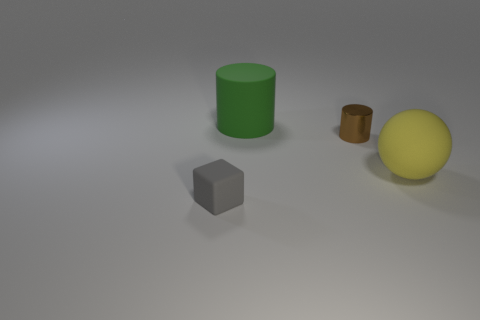Add 1 yellow spheres. How many objects exist? 5 Subtract all balls. How many objects are left? 3 Subtract all yellow rubber balls. Subtract all large spheres. How many objects are left? 2 Add 1 big cylinders. How many big cylinders are left? 2 Add 1 small gray matte blocks. How many small gray matte blocks exist? 2 Subtract 0 brown spheres. How many objects are left? 4 Subtract 2 cylinders. How many cylinders are left? 0 Subtract all gray cylinders. Subtract all brown cubes. How many cylinders are left? 2 Subtract all red blocks. How many brown cylinders are left? 1 